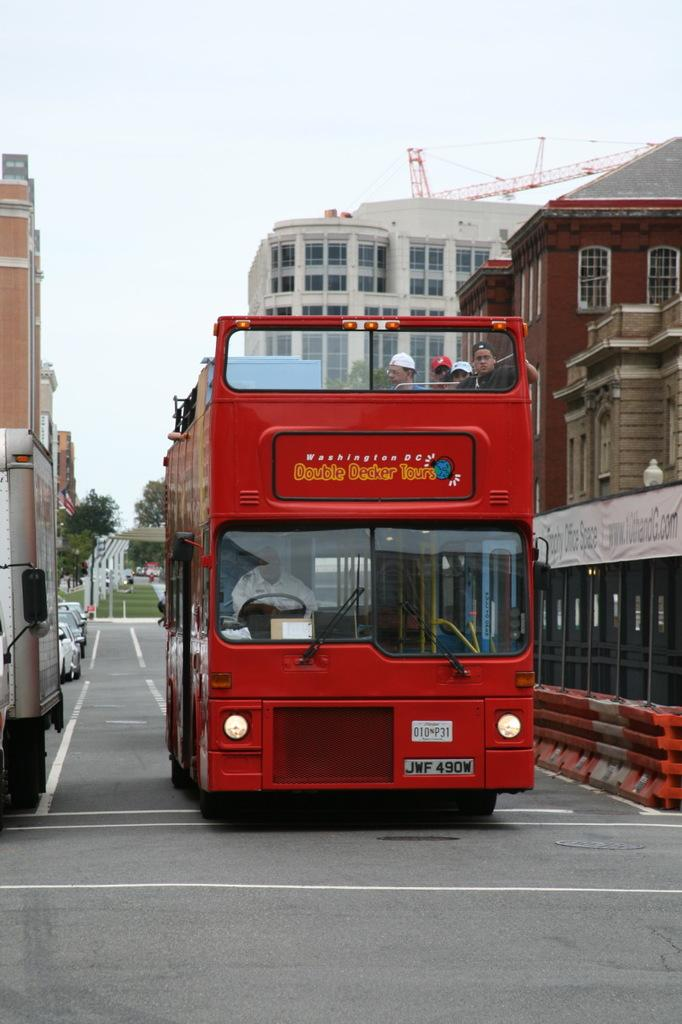What can be seen on the road in the image? There are vehicles on the road in the image. What type of vehicle is carrying people in the image? There are people seated in a bus in the image. What can be seen in the background of the image? There are trees, buildings, and a crane visible in the background of the image. What type of bread is being copied in the image? There is no bread or copying activity present in the image. What is the aftermath of the event in the image? There is no event or aftermath depicted in the image; it shows vehicles on the road, a bus with people, and the background with trees, buildings, and a crane. 